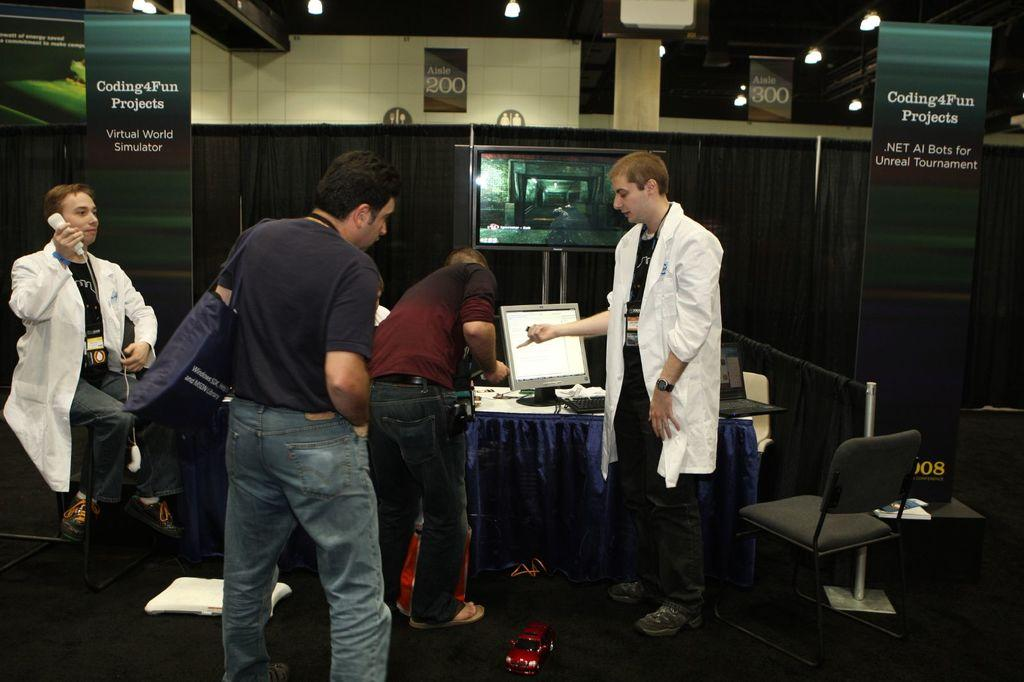How many persons are present in the image? There are four persons on the floor in the image. What type of furniture can be seen in the image? There are chairs and a table in the image. What electronic devices are visible in the image? There is a PC and laptops in the image. What can be seen in the background of the image? There is a wall, boards, a curtain, and lights in the background of the image. Where was the image taken? The image was taken in a hall. How does the structure of the ground affect the increase in temperature in the image? There is no mention of the ground's structure or an increase in temperature in the image. The image shows four persons, furniture, electronic devices, and background elements in a hall. 